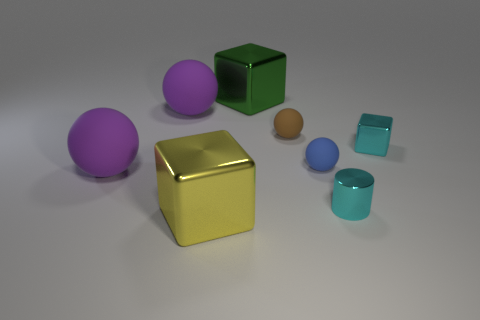Subtract all big cubes. How many cubes are left? 1 Subtract all blue spheres. How many spheres are left? 3 Add 1 yellow matte objects. How many objects exist? 9 Subtract all gray spheres. Subtract all blue cylinders. How many spheres are left? 4 Subtract all cylinders. How many objects are left? 7 Add 5 balls. How many balls are left? 9 Add 4 cylinders. How many cylinders exist? 5 Subtract 0 brown cubes. How many objects are left? 8 Subtract all tiny brown objects. Subtract all red matte cylinders. How many objects are left? 7 